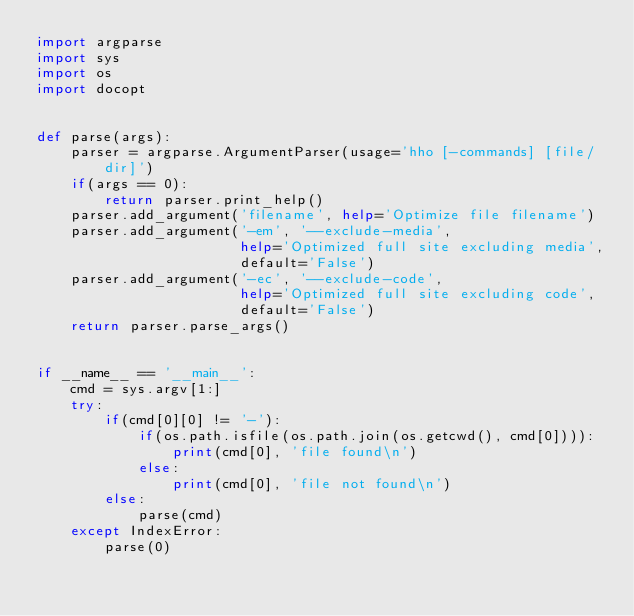<code> <loc_0><loc_0><loc_500><loc_500><_Python_>import argparse
import sys
import os
import docopt


def parse(args):
    parser = argparse.ArgumentParser(usage='hho [-commands] [file/dir]')
    if(args == 0):
        return parser.print_help()
    parser.add_argument('filename', help='Optimize file filename')
    parser.add_argument('-em', '--exclude-media',
                        help='Optimized full site excluding media',
                        default='False')
    parser.add_argument('-ec', '--exclude-code',
                        help='Optimized full site excluding code',
                        default='False')
    return parser.parse_args()


if __name__ == '__main__':
    cmd = sys.argv[1:]
    try:
        if(cmd[0][0] != '-'):
            if(os.path.isfile(os.path.join(os.getcwd(), cmd[0]))):
                print(cmd[0], 'file found\n')
            else:
                print(cmd[0], 'file not found\n')
        else:
            parse(cmd)
    except IndexError:
        parse(0)
</code> 